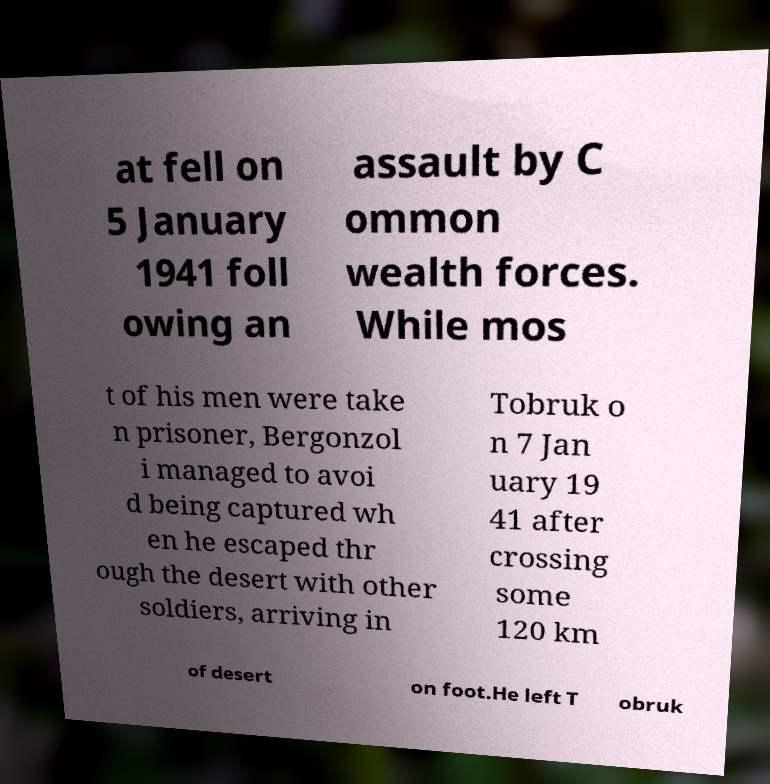Can you read and provide the text displayed in the image?This photo seems to have some interesting text. Can you extract and type it out for me? at fell on 5 January 1941 foll owing an assault by C ommon wealth forces. While mos t of his men were take n prisoner, Bergonzol i managed to avoi d being captured wh en he escaped thr ough the desert with other soldiers, arriving in Tobruk o n 7 Jan uary 19 41 after crossing some 120 km of desert on foot.He left T obruk 